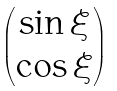<formula> <loc_0><loc_0><loc_500><loc_500>\begin{pmatrix} \sin \xi \\ \cos \xi \end{pmatrix}</formula> 